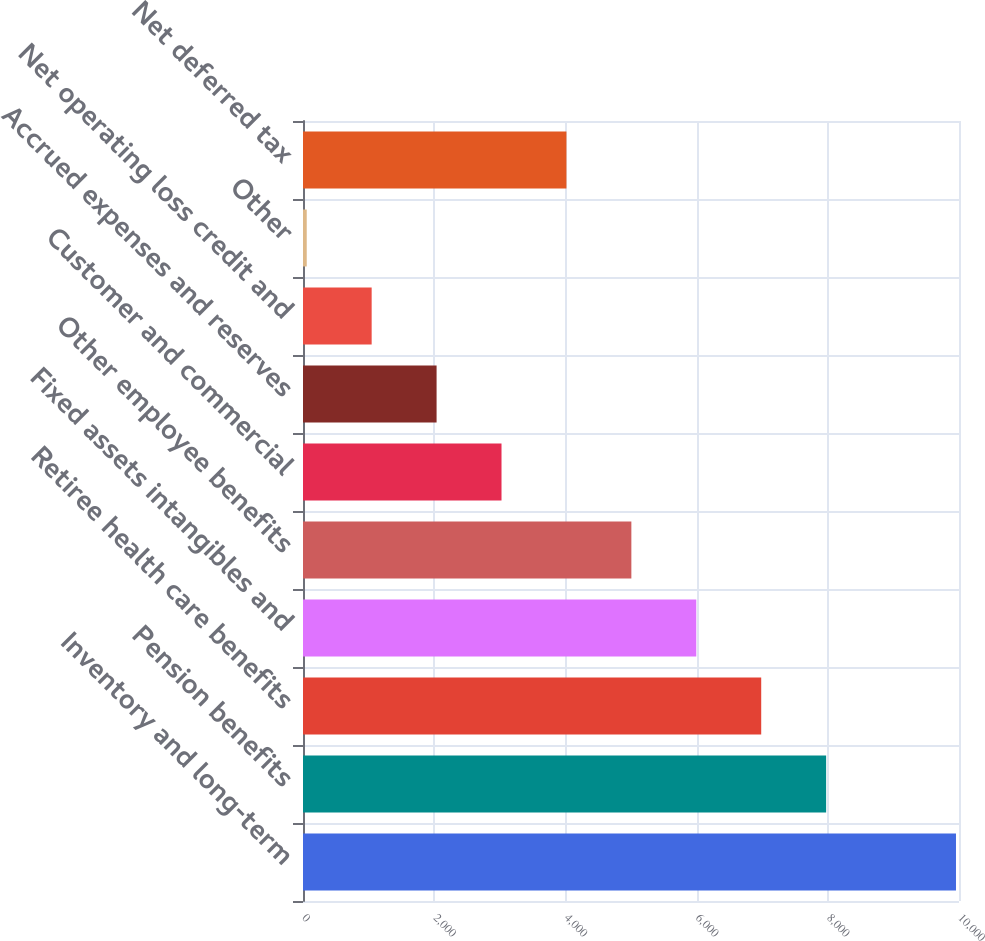Convert chart. <chart><loc_0><loc_0><loc_500><loc_500><bar_chart><fcel>Inventory and long-term<fcel>Pension benefits<fcel>Retiree health care benefits<fcel>Fixed assets intangibles and<fcel>Other employee benefits<fcel>Customer and commercial<fcel>Accrued expenses and reserves<fcel>Net operating loss credit and<fcel>Other<fcel>Net deferred tax<nl><fcel>9954<fcel>7974.6<fcel>6984.9<fcel>5995.2<fcel>5005.5<fcel>3026.1<fcel>2036.4<fcel>1046.7<fcel>57<fcel>4015.8<nl></chart> 